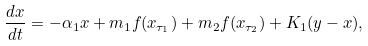<formula> <loc_0><loc_0><loc_500><loc_500>\frac { d x } { d t } = - \alpha _ { 1 } x + m _ { 1 } f ( x _ { \tau _ { 1 } } ) + m _ { 2 } f ( x _ { \tau _ { 2 } } ) + K _ { 1 } ( y - x ) ,</formula> 